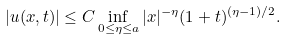<formula> <loc_0><loc_0><loc_500><loc_500>| u ( x , t ) | \leq C \inf _ { 0 \leq \eta \leq a } | x | ^ { - \eta } ( 1 + t ) ^ { ( \eta - 1 ) / 2 } .</formula> 